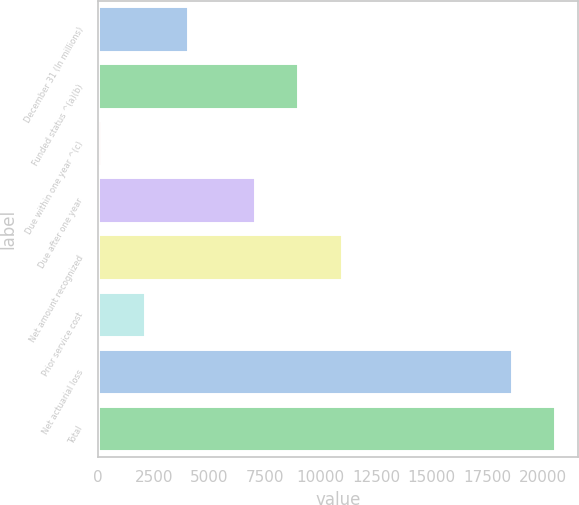Convert chart to OTSL. <chart><loc_0><loc_0><loc_500><loc_500><bar_chart><fcel>December 31 (In millions)<fcel>Funded status ^(a)(b)<fcel>Due within one year ^(c)<fcel>Due after one year<fcel>Net amount recognized<fcel>Prior service cost<fcel>Net actuarial loss<fcel>Total<nl><fcel>4048.4<fcel>9010.7<fcel>141<fcel>7057<fcel>10964.4<fcel>2094.7<fcel>18603<fcel>20556.7<nl></chart> 